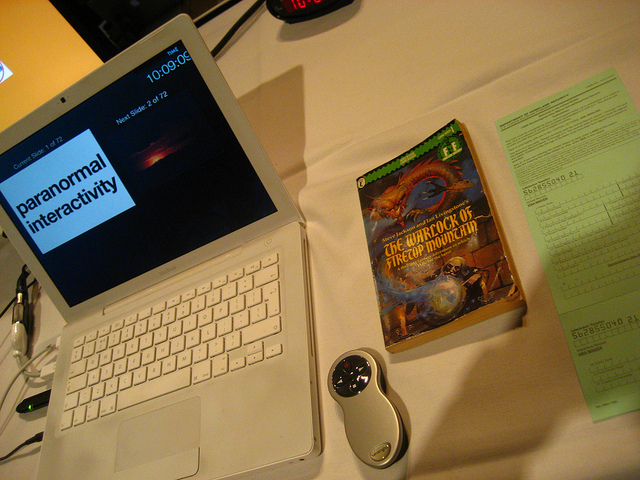Read and extract the text from this image. paranormal interactivity WHRLOCK MOUNTAIN FIRECOP 562855040 OF THE 562855040 10:09:09 